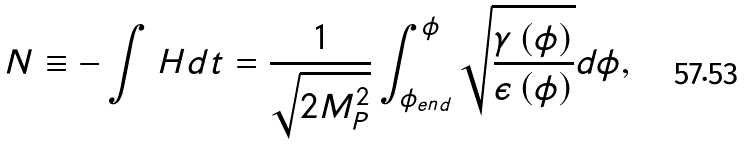<formula> <loc_0><loc_0><loc_500><loc_500>N \equiv - \int { H } { d t } = \frac { 1 } { \sqrt { 2 M _ { P } ^ { 2 } } } \int _ { \phi _ { e n d } } ^ { \phi } { \sqrt { \frac { \gamma \left ( \phi \right ) } { \epsilon \left ( \phi \right ) } } d \phi } ,</formula> 